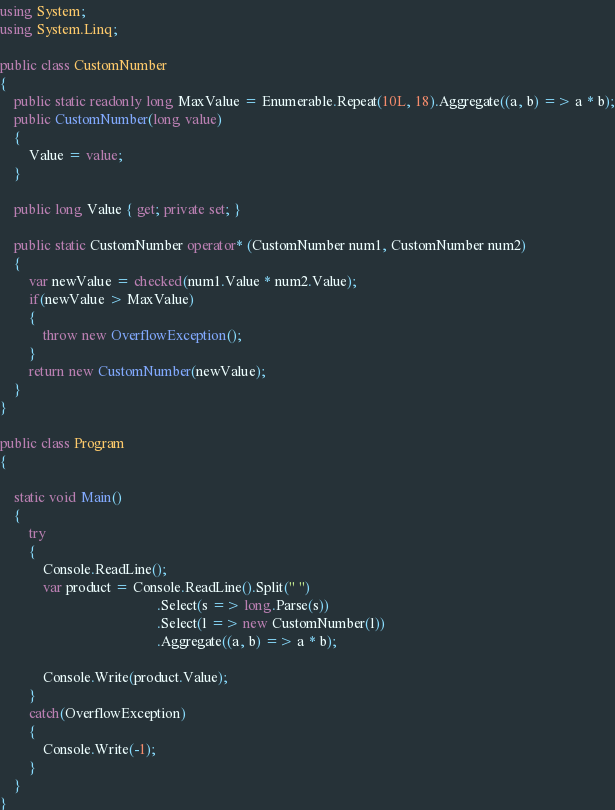Convert code to text. <code><loc_0><loc_0><loc_500><loc_500><_C#_>using System;
using System.Linq;

public class CustomNumber
{
    public static readonly long MaxValue = Enumerable.Repeat(10L, 18).Aggregate((a, b) => a * b);
    public CustomNumber(long value)
    {
        Value = value;
    }

    public long Value { get; private set; }

    public static CustomNumber operator* (CustomNumber num1, CustomNumber num2)
    {
        var newValue = checked(num1.Value * num2.Value);
        if(newValue > MaxValue)
        {
            throw new OverflowException();
        }
        return new CustomNumber(newValue);
    }
}

public class Program
{

    static void Main()
    {
        try
        {
            Console.ReadLine();
            var product = Console.ReadLine().Split(" ")
                                            .Select(s => long.Parse(s))
                                            .Select(l => new CustomNumber(l))
                                            .Aggregate((a, b) => a * b);

            Console.Write(product.Value);
        } 
        catch(OverflowException)
        {
            Console.Write(-1);
        }
    }
}
</code> 